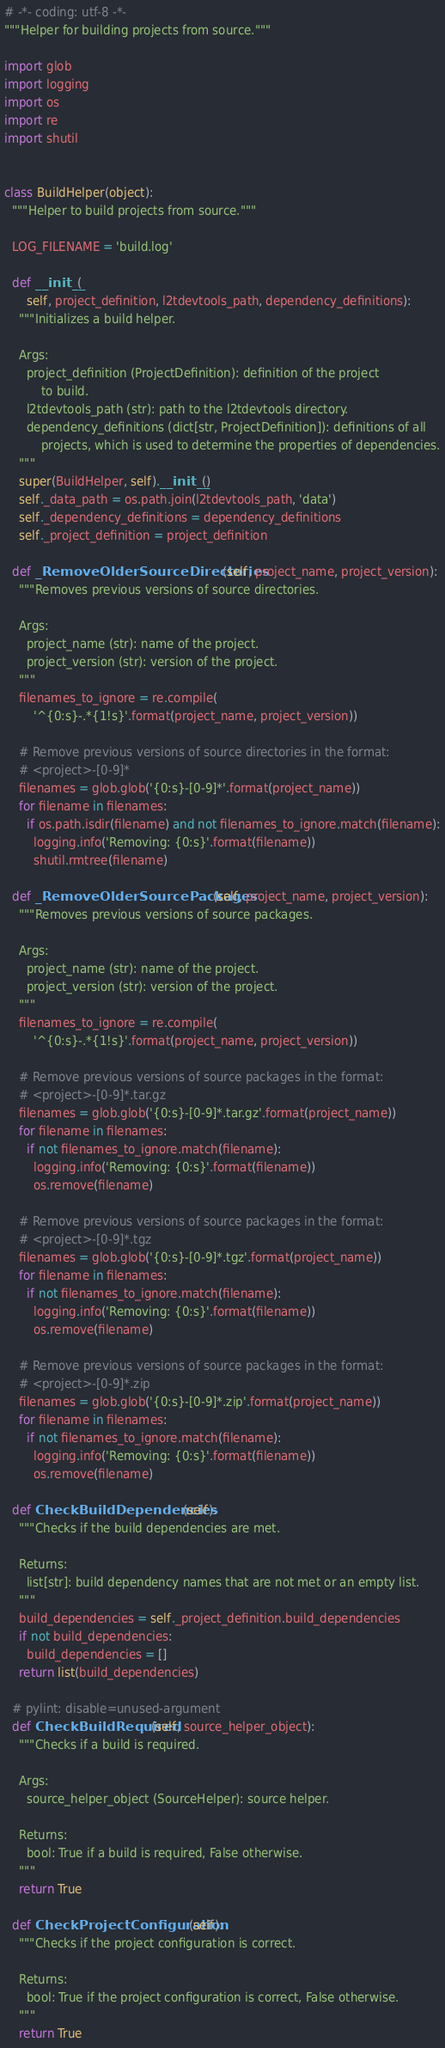Convert code to text. <code><loc_0><loc_0><loc_500><loc_500><_Python_># -*- coding: utf-8 -*-
"""Helper for building projects from source."""

import glob
import logging
import os
import re
import shutil


class BuildHelper(object):
  """Helper to build projects from source."""

  LOG_FILENAME = 'build.log'

  def __init__(
      self, project_definition, l2tdevtools_path, dependency_definitions):
    """Initializes a build helper.

    Args:
      project_definition (ProjectDefinition): definition of the project
          to build.
      l2tdevtools_path (str): path to the l2tdevtools directory.
      dependency_definitions (dict[str, ProjectDefinition]): definitions of all
          projects, which is used to determine the properties of dependencies.
    """
    super(BuildHelper, self).__init__()
    self._data_path = os.path.join(l2tdevtools_path, 'data')
    self._dependency_definitions = dependency_definitions
    self._project_definition = project_definition

  def _RemoveOlderSourceDirectories(self, project_name, project_version):
    """Removes previous versions of source directories.

    Args:
      project_name (str): name of the project.
      project_version (str): version of the project.
    """
    filenames_to_ignore = re.compile(
        '^{0:s}-.*{1!s}'.format(project_name, project_version))

    # Remove previous versions of source directories in the format:
    # <project>-[0-9]*
    filenames = glob.glob('{0:s}-[0-9]*'.format(project_name))
    for filename in filenames:
      if os.path.isdir(filename) and not filenames_to_ignore.match(filename):
        logging.info('Removing: {0:s}'.format(filename))
        shutil.rmtree(filename)

  def _RemoveOlderSourcePackages(self, project_name, project_version):
    """Removes previous versions of source packages.

    Args:
      project_name (str): name of the project.
      project_version (str): version of the project.
    """
    filenames_to_ignore = re.compile(
        '^{0:s}-.*{1!s}'.format(project_name, project_version))

    # Remove previous versions of source packages in the format:
    # <project>-[0-9]*.tar.gz
    filenames = glob.glob('{0:s}-[0-9]*.tar.gz'.format(project_name))
    for filename in filenames:
      if not filenames_to_ignore.match(filename):
        logging.info('Removing: {0:s}'.format(filename))
        os.remove(filename)

    # Remove previous versions of source packages in the format:
    # <project>-[0-9]*.tgz
    filenames = glob.glob('{0:s}-[0-9]*.tgz'.format(project_name))
    for filename in filenames:
      if not filenames_to_ignore.match(filename):
        logging.info('Removing: {0:s}'.format(filename))
        os.remove(filename)

    # Remove previous versions of source packages in the format:
    # <project>-[0-9]*.zip
    filenames = glob.glob('{0:s}-[0-9]*.zip'.format(project_name))
    for filename in filenames:
      if not filenames_to_ignore.match(filename):
        logging.info('Removing: {0:s}'.format(filename))
        os.remove(filename)

  def CheckBuildDependencies(self):
    """Checks if the build dependencies are met.

    Returns:
      list[str]: build dependency names that are not met or an empty list.
    """
    build_dependencies = self._project_definition.build_dependencies
    if not build_dependencies:
      build_dependencies = []
    return list(build_dependencies)

  # pylint: disable=unused-argument
  def CheckBuildRequired(self, source_helper_object):
    """Checks if a build is required.

    Args:
      source_helper_object (SourceHelper): source helper.

    Returns:
      bool: True if a build is required, False otherwise.
    """
    return True

  def CheckProjectConfiguration(self):
    """Checks if the project configuration is correct.

    Returns:
      bool: True if the project configuration is correct, False otherwise.
    """
    return True
</code> 